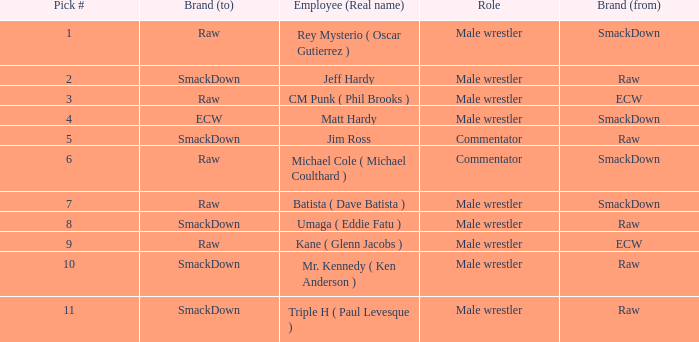Pick # 3 works for which brand? ECW. Would you mind parsing the complete table? {'header': ['Pick #', 'Brand (to)', 'Employee (Real name)', 'Role', 'Brand (from)'], 'rows': [['1', 'Raw', 'Rey Mysterio ( Oscar Gutierrez )', 'Male wrestler', 'SmackDown'], ['2', 'SmackDown', 'Jeff Hardy', 'Male wrestler', 'Raw'], ['3', 'Raw', 'CM Punk ( Phil Brooks )', 'Male wrestler', 'ECW'], ['4', 'ECW', 'Matt Hardy', 'Male wrestler', 'SmackDown'], ['5', 'SmackDown', 'Jim Ross', 'Commentator', 'Raw'], ['6', 'Raw', 'Michael Cole ( Michael Coulthard )', 'Commentator', 'SmackDown'], ['7', 'Raw', 'Batista ( Dave Batista )', 'Male wrestler', 'SmackDown'], ['8', 'SmackDown', 'Umaga ( Eddie Fatu )', 'Male wrestler', 'Raw'], ['9', 'Raw', 'Kane ( Glenn Jacobs )', 'Male wrestler', 'ECW'], ['10', 'SmackDown', 'Mr. Kennedy ( Ken Anderson )', 'Male wrestler', 'Raw'], ['11', 'SmackDown', 'Triple H ( Paul Levesque )', 'Male wrestler', 'Raw']]} 